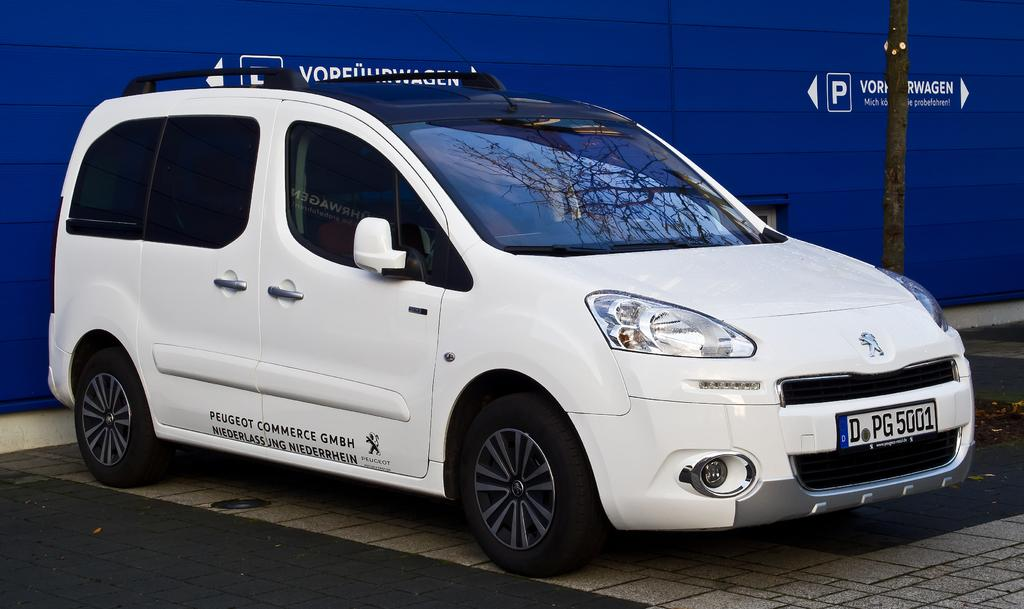What is the main subject of the image? The main subject of the image is a car. What else can be seen in the image besides the car? There is a pole in the image. What is visible in the background of the image? There is text on a wall in the background of the image. What type of beef is being advertised on the car in the image? There is no beef being advertised on the car in the image; the text on the wall in the background is not related to beef. 